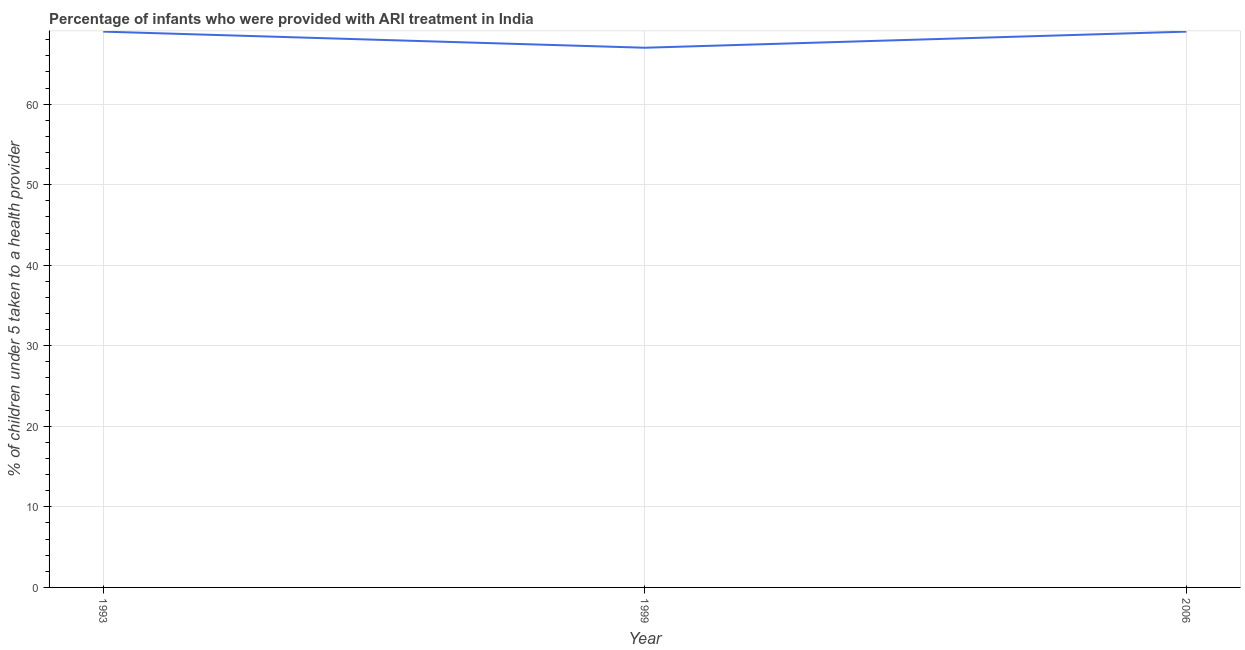What is the percentage of children who were provided with ari treatment in 1999?
Offer a terse response. 67. Across all years, what is the maximum percentage of children who were provided with ari treatment?
Give a very brief answer. 69. Across all years, what is the minimum percentage of children who were provided with ari treatment?
Your answer should be very brief. 67. In which year was the percentage of children who were provided with ari treatment maximum?
Your answer should be very brief. 1993. What is the sum of the percentage of children who were provided with ari treatment?
Make the answer very short. 205. What is the difference between the percentage of children who were provided with ari treatment in 1999 and 2006?
Provide a succinct answer. -2. What is the average percentage of children who were provided with ari treatment per year?
Your answer should be very brief. 68.33. What is the median percentage of children who were provided with ari treatment?
Ensure brevity in your answer.  69. Do a majority of the years between 2006 and 1993 (inclusive) have percentage of children who were provided with ari treatment greater than 22 %?
Provide a succinct answer. No. What is the ratio of the percentage of children who were provided with ari treatment in 1993 to that in 1999?
Provide a short and direct response. 1.03. What is the difference between the highest and the lowest percentage of children who were provided with ari treatment?
Provide a short and direct response. 2. In how many years, is the percentage of children who were provided with ari treatment greater than the average percentage of children who were provided with ari treatment taken over all years?
Provide a succinct answer. 2. Does the percentage of children who were provided with ari treatment monotonically increase over the years?
Your answer should be compact. No. How many years are there in the graph?
Give a very brief answer. 3. What is the difference between two consecutive major ticks on the Y-axis?
Offer a terse response. 10. Are the values on the major ticks of Y-axis written in scientific E-notation?
Offer a very short reply. No. Does the graph contain any zero values?
Ensure brevity in your answer.  No. Does the graph contain grids?
Your response must be concise. Yes. What is the title of the graph?
Your response must be concise. Percentage of infants who were provided with ARI treatment in India. What is the label or title of the Y-axis?
Your answer should be very brief. % of children under 5 taken to a health provider. What is the % of children under 5 taken to a health provider in 1993?
Provide a short and direct response. 69. What is the % of children under 5 taken to a health provider of 2006?
Offer a very short reply. 69. What is the difference between the % of children under 5 taken to a health provider in 1993 and 2006?
Offer a terse response. 0. What is the ratio of the % of children under 5 taken to a health provider in 1993 to that in 1999?
Provide a succinct answer. 1.03. 